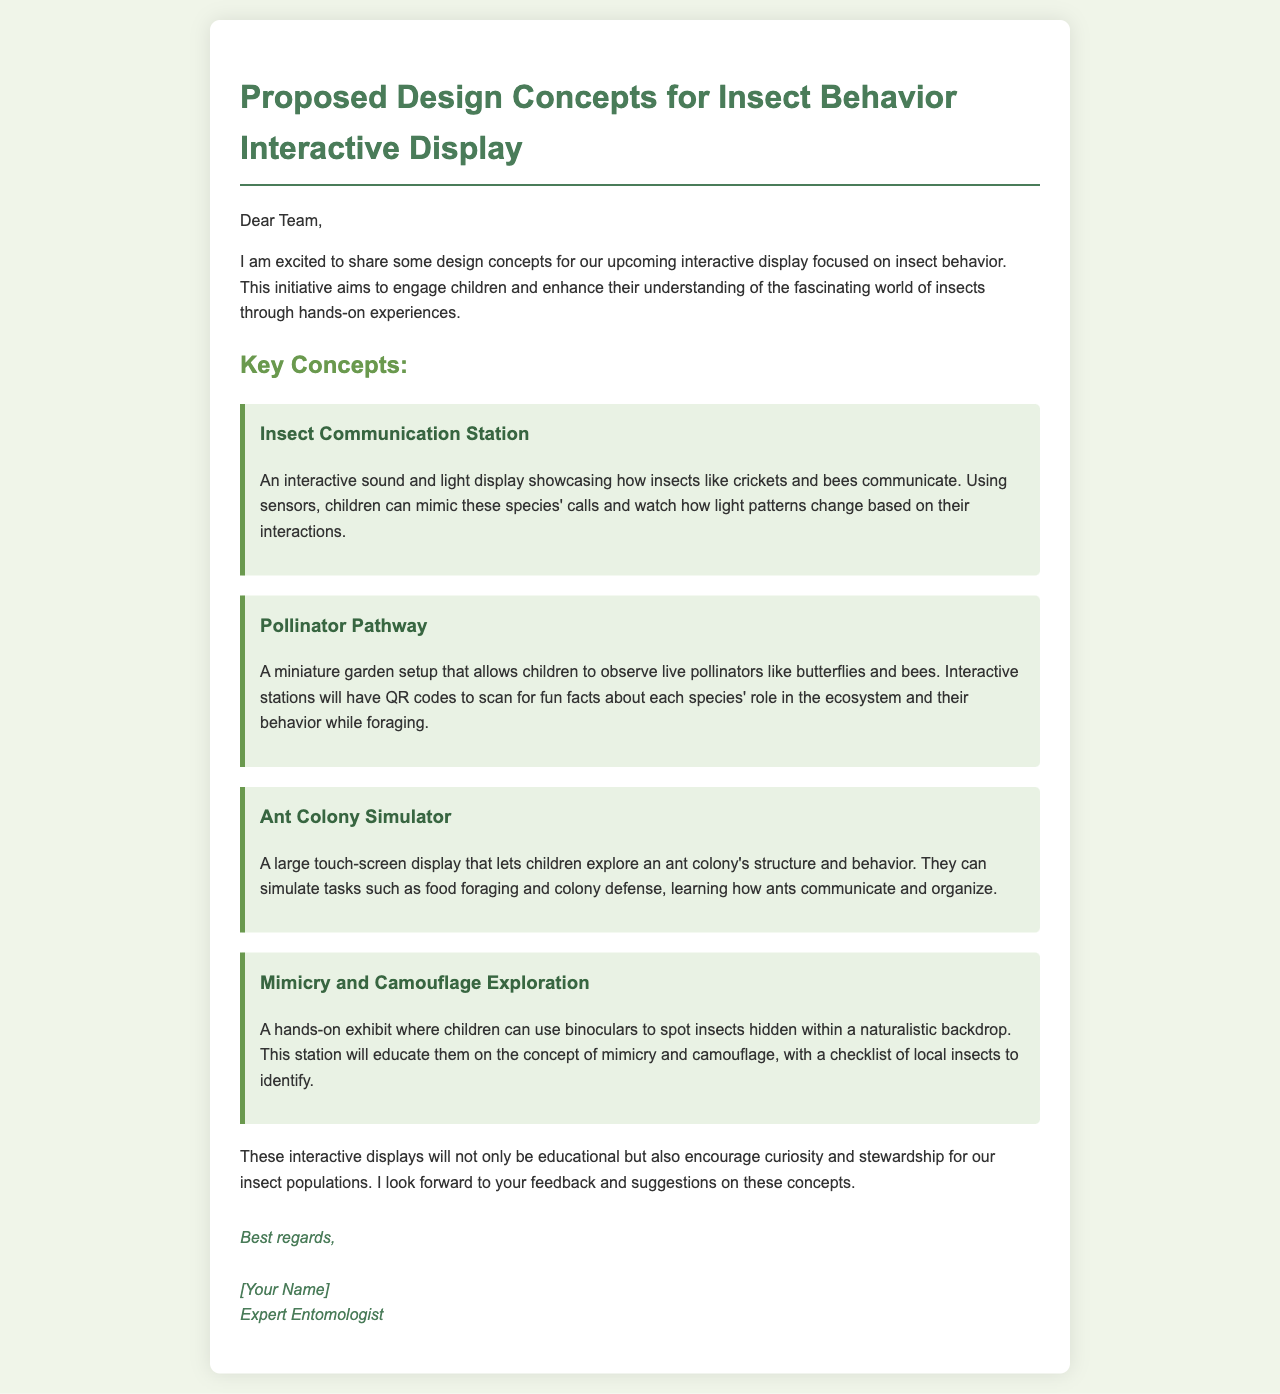what are the key concepts of the display? The key concepts are listed under the "Key Concepts:" section and include interactive exhibits focused on insect behavior.
Answer: Insect Communication Station, Pollinator Pathway, Ant Colony Simulator, Mimicry and Camouflage Exploration how many interactive displays are proposed? The total number of individual concepts shared in the document indicates the quantity of displays proposed.
Answer: Four who is the sender of the email? The name provided in the signature at the end of the email identifies the sender.
Answer: [Your Name] what insect communicates using sound in the display? The example given in the "Insect Communication Station" indicates a specific insect that uses sound to communicate.
Answer: Crickets what educational purpose do these displays serve? The last paragraph discusses the objectives and benefits of the displays, particularly for children's learning.
Answer: Educate which concept allows children to observe live pollinators? The relevant section describes a setup that involves observing live pollinators.
Answer: Pollinator Pathway what is the main interaction method in the "Ant Colony Simulator"? The method described in the corresponding section outlines how children engage with this interactive display.
Answer: Touch-screen display what type of insects are the focus for mimicry and camouflage exploration? The section on camouflage mentions the group of insects that children will be identifying.
Answer: Local insects 